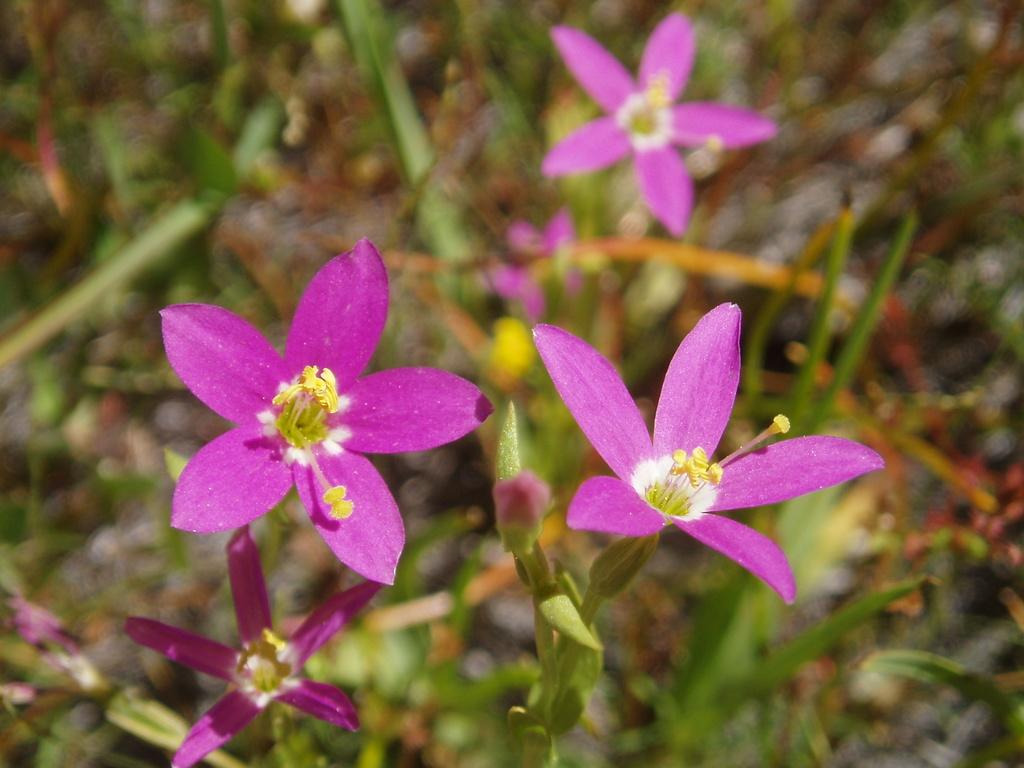What types of living organisms can be seen in the image? Plants and flowers are visible in the image. Can you describe the stage of growth for some of the plants in the image? Yes, there are buds in the image, which suggests that some of the plants are in the early stages of growth. What type of fan can be seen in the image? There is no fan present in the image. What amusement park ride can be seen in the image? There is no amusement park ride present in the image. 